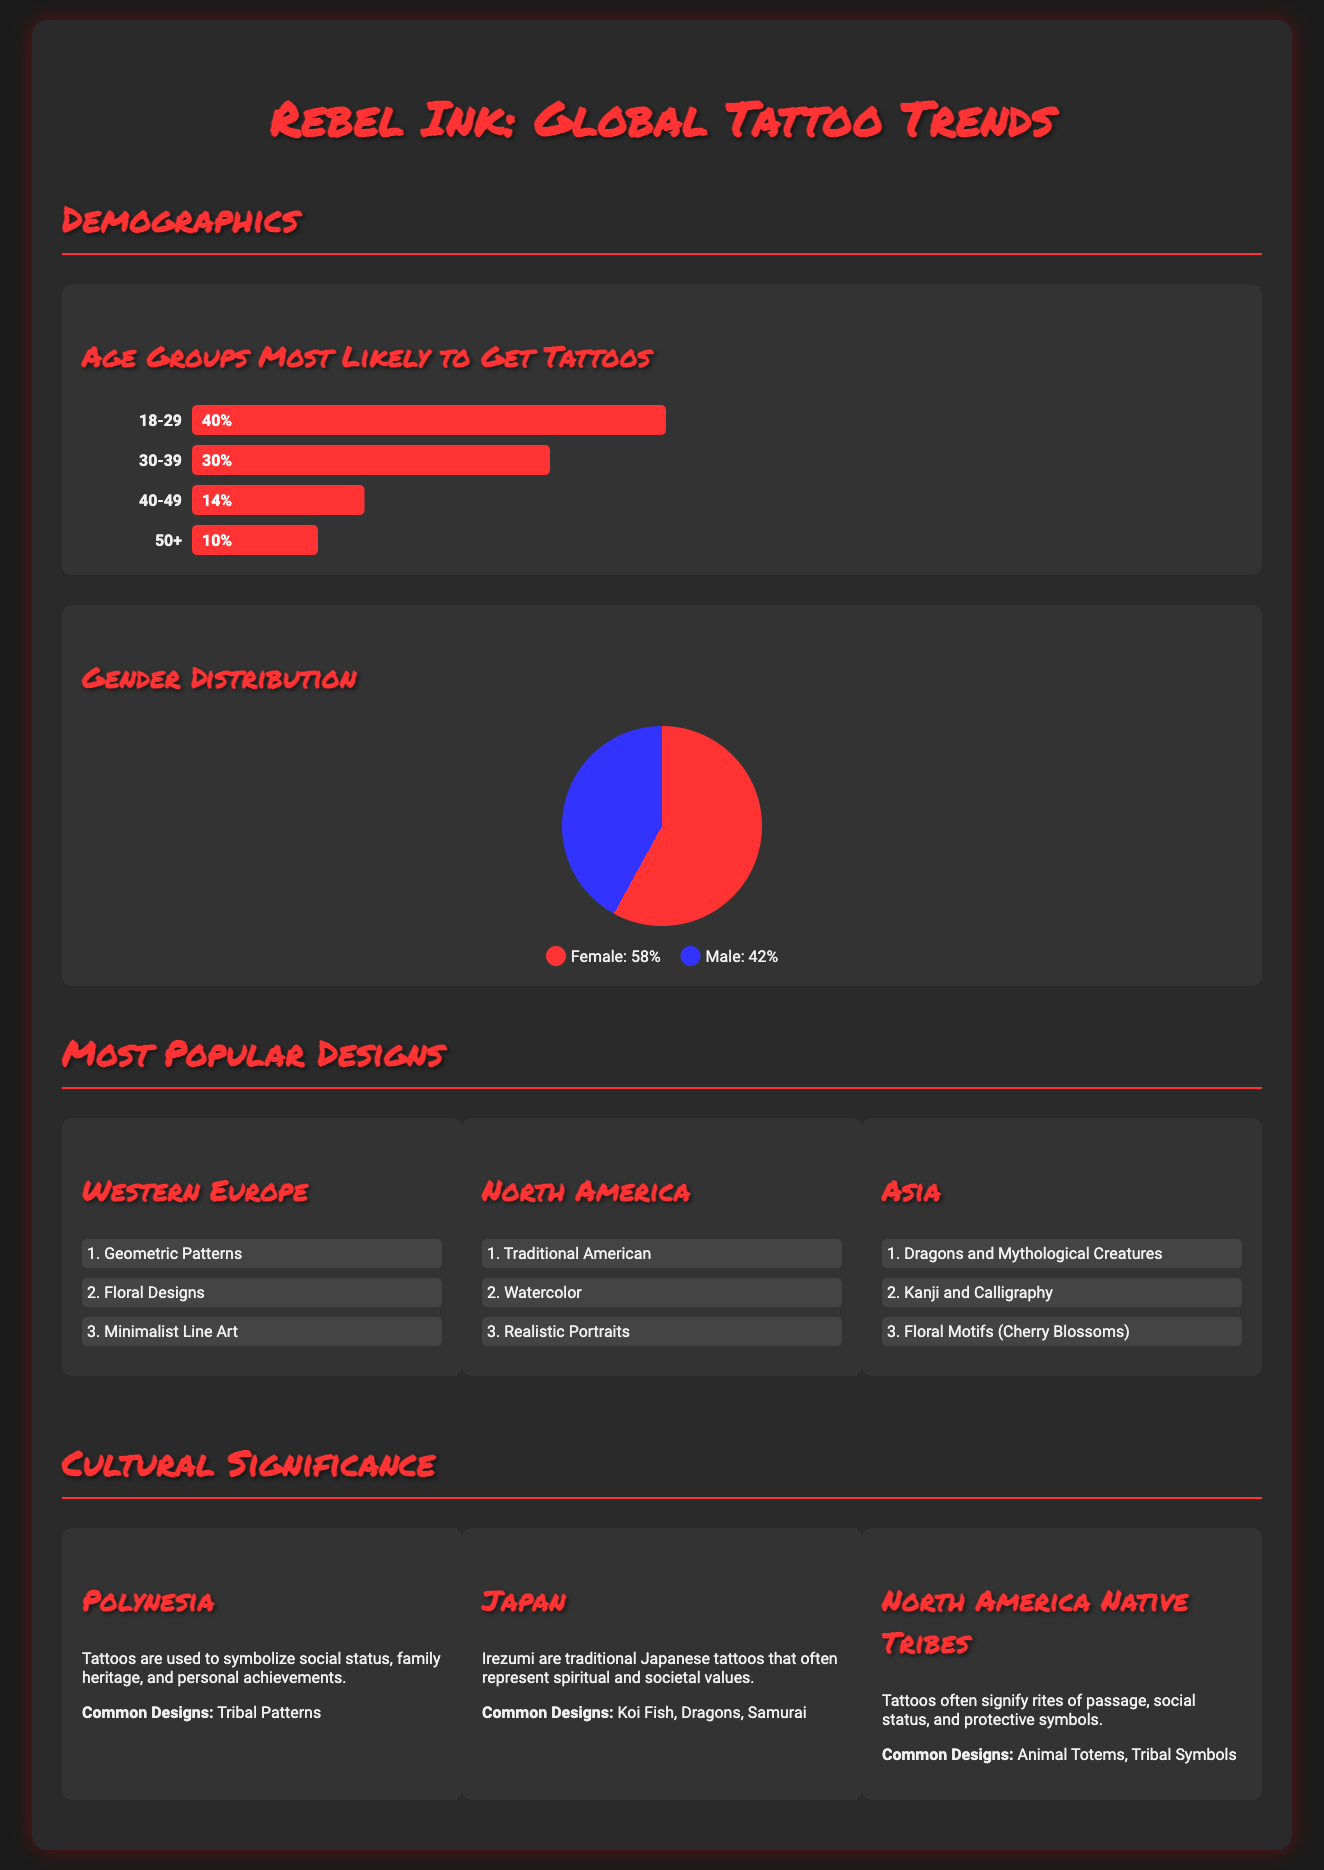What percentage of people aged 18-29 get tattoos? The document states that 40% of individuals in the age group 18-29 are likely to get tattoos.
Answer: 40% What is the gender distribution of tattoo enthusiasts? The infographic provides a pie chart showing that 58% are female and 42% are male.
Answer: Female: 58%, Male: 42% Which tattoo design is most popular in North America? In the North America section, "Traditional American" is listed as the most popular design.
Answer: Traditional American What are common tattoo designs in Japan? The document mentions Irezumi designs, including Koi Fish, Dragons, and Samurai as common in Japan.
Answer: Koi Fish, Dragons, Samurai How do tattoos signify in Polynesia? The cultural significance section explains that tattoos symbolize social status, family heritage, and personal achievements in Polynesia.
Answer: Social status, family heritage, personal achievements What is the second most popular tattoo design in Western Europe? The second design mentioned for Western Europe is "Floral Designs."
Answer: Floral Designs What age group has the least likelihood to get tattoos? According to the demographic information, the age group 50+ shows the least likelihood at 10%.
Answer: 50+ What type of design is popular in Asia? The infographic highlights "Dragons and Mythological Creatures" as the most popular design in Asia.
Answer: Dragons and Mythological Creatures 